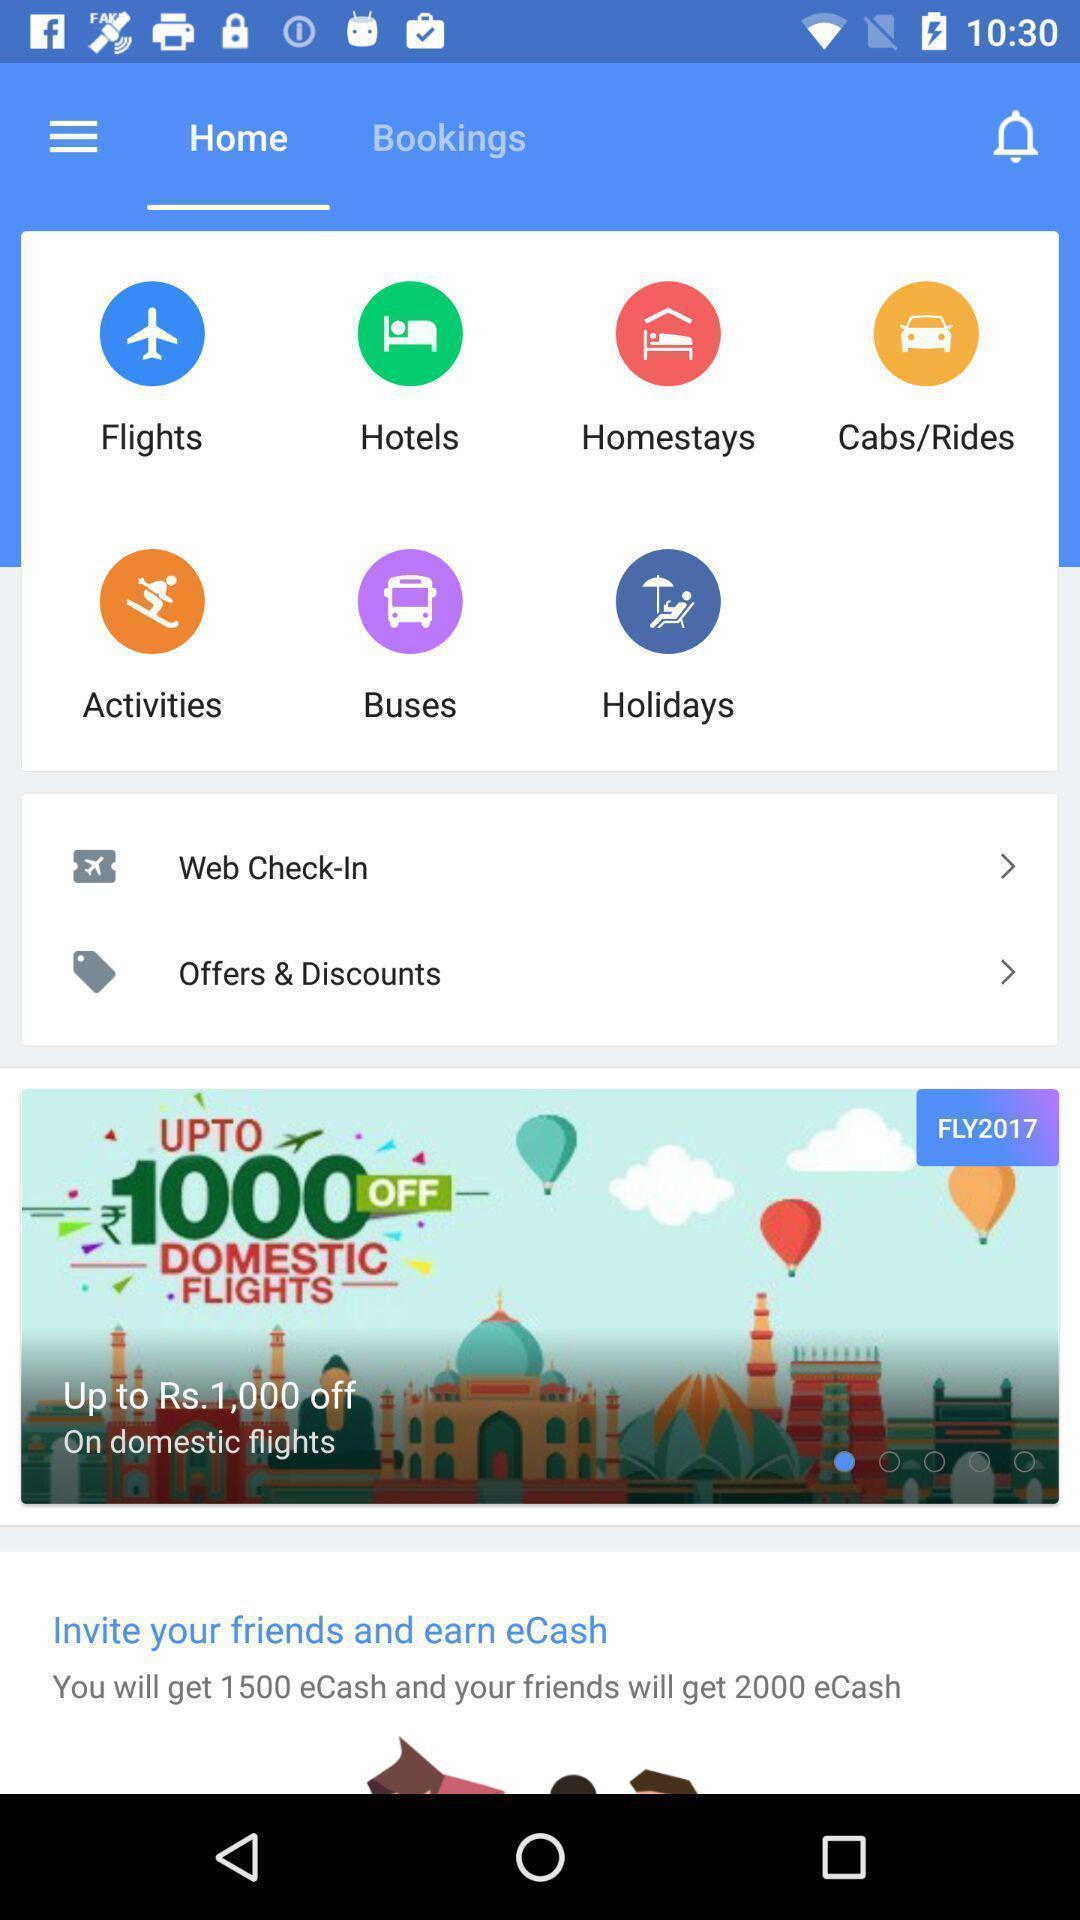Summarize the main components in this picture. Screen shows home page. 